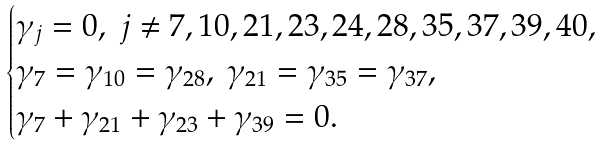<formula> <loc_0><loc_0><loc_500><loc_500>\begin{cases} \gamma _ { j } = 0 , \ j \ne 7 , 1 0 , 2 1 , 2 3 , 2 4 , 2 8 , 3 5 , 3 7 , 3 9 , 4 0 , \\ \gamma _ { 7 } = \gamma _ { 1 0 } = \gamma _ { 2 8 } , \ \gamma _ { 2 1 } = \gamma _ { 3 5 } = \gamma _ { 3 7 } , \\ \gamma _ { 7 } + \gamma _ { 2 1 } + \gamma _ { 2 3 } + \gamma _ { 3 9 } = 0 . \end{cases}</formula> 